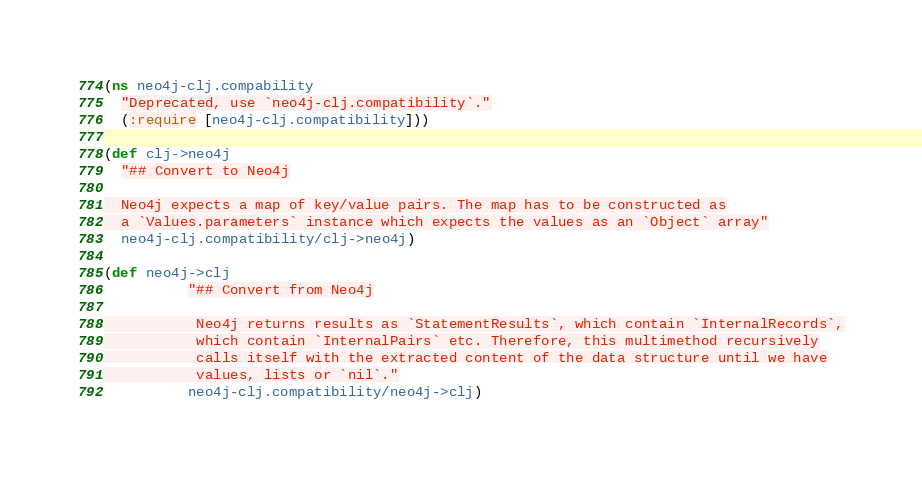<code> <loc_0><loc_0><loc_500><loc_500><_Clojure_>(ns neo4j-clj.compability
  "Deprecated, use `neo4j-clj.compatibility`."
  (:require [neo4j-clj.compatibility]))

(def clj->neo4j
  "## Convert to Neo4j

  Neo4j expects a map of key/value pairs. The map has to be constructed as
  a `Values.parameters` instance which expects the values as an `Object` array"
  neo4j-clj.compatibility/clj->neo4j)

(def neo4j->clj
          "## Convert from Neo4j

           Neo4j returns results as `StatementResults`, which contain `InternalRecords`,
           which contain `InternalPairs` etc. Therefore, this multimethod recursively
           calls itself with the extracted content of the data structure until we have
           values, lists or `nil`."
          neo4j-clj.compatibility/neo4j->clj)</code> 